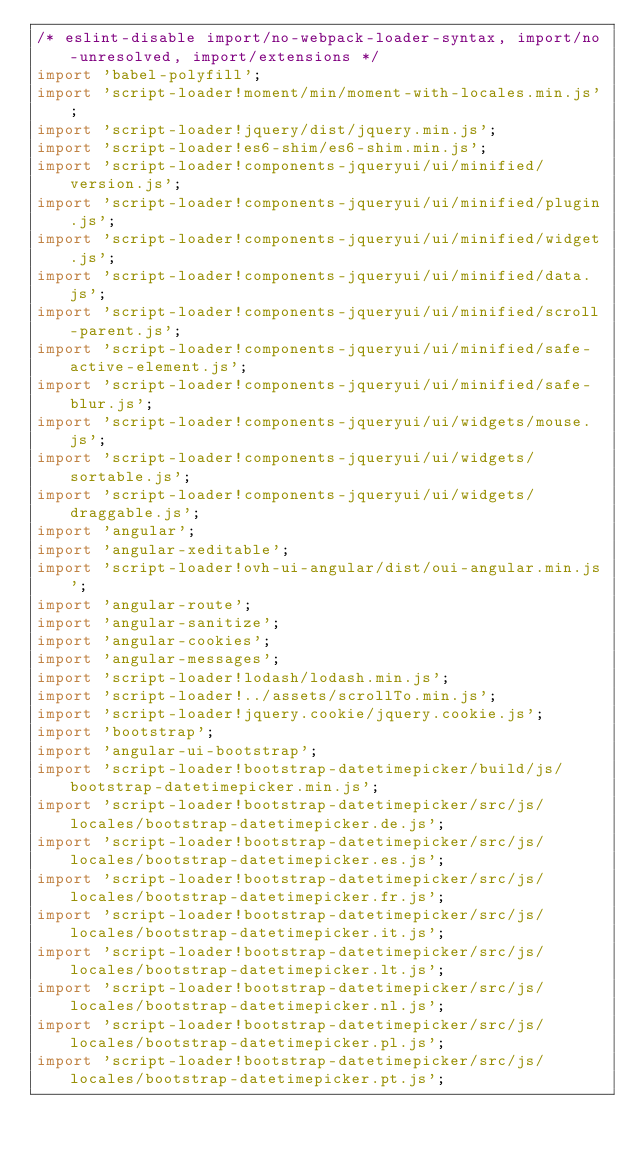<code> <loc_0><loc_0><loc_500><loc_500><_JavaScript_>/* eslint-disable import/no-webpack-loader-syntax, import/no-unresolved, import/extensions */
import 'babel-polyfill';
import 'script-loader!moment/min/moment-with-locales.min.js';
import 'script-loader!jquery/dist/jquery.min.js';
import 'script-loader!es6-shim/es6-shim.min.js';
import 'script-loader!components-jqueryui/ui/minified/version.js';
import 'script-loader!components-jqueryui/ui/minified/plugin.js';
import 'script-loader!components-jqueryui/ui/minified/widget.js';
import 'script-loader!components-jqueryui/ui/minified/data.js';
import 'script-loader!components-jqueryui/ui/minified/scroll-parent.js';
import 'script-loader!components-jqueryui/ui/minified/safe-active-element.js';
import 'script-loader!components-jqueryui/ui/minified/safe-blur.js';
import 'script-loader!components-jqueryui/ui/widgets/mouse.js';
import 'script-loader!components-jqueryui/ui/widgets/sortable.js';
import 'script-loader!components-jqueryui/ui/widgets/draggable.js';
import 'angular';
import 'angular-xeditable';
import 'script-loader!ovh-ui-angular/dist/oui-angular.min.js';
import 'angular-route';
import 'angular-sanitize';
import 'angular-cookies';
import 'angular-messages';
import 'script-loader!lodash/lodash.min.js';
import 'script-loader!../assets/scrollTo.min.js';
import 'script-loader!jquery.cookie/jquery.cookie.js';
import 'bootstrap';
import 'angular-ui-bootstrap';
import 'script-loader!bootstrap-datetimepicker/build/js/bootstrap-datetimepicker.min.js';
import 'script-loader!bootstrap-datetimepicker/src/js/locales/bootstrap-datetimepicker.de.js';
import 'script-loader!bootstrap-datetimepicker/src/js/locales/bootstrap-datetimepicker.es.js';
import 'script-loader!bootstrap-datetimepicker/src/js/locales/bootstrap-datetimepicker.fr.js';
import 'script-loader!bootstrap-datetimepicker/src/js/locales/bootstrap-datetimepicker.it.js';
import 'script-loader!bootstrap-datetimepicker/src/js/locales/bootstrap-datetimepicker.lt.js';
import 'script-loader!bootstrap-datetimepicker/src/js/locales/bootstrap-datetimepicker.nl.js';
import 'script-loader!bootstrap-datetimepicker/src/js/locales/bootstrap-datetimepicker.pl.js';
import 'script-loader!bootstrap-datetimepicker/src/js/locales/bootstrap-datetimepicker.pt.js';</code> 